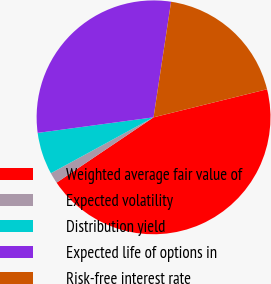<chart> <loc_0><loc_0><loc_500><loc_500><pie_chart><fcel>Weighted average fair value of<fcel>Expected volatility<fcel>Distribution yield<fcel>Expected life of options in<fcel>Risk-free interest rate<nl><fcel>44.42%<fcel>1.5%<fcel>5.81%<fcel>29.52%<fcel>18.74%<nl></chart> 